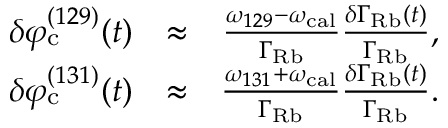<formula> <loc_0><loc_0><loc_500><loc_500>\begin{array} { r l r } { \delta \varphi _ { c } ^ { ( 1 2 9 ) } ( t ) } & { \approx } & { \frac { \omega _ { 1 2 9 } - \omega _ { c a l } } { \Gamma _ { R b } } \frac { \delta \Gamma _ { R b } ( t ) } { \Gamma _ { R b } } , } \\ { \delta \varphi _ { c } ^ { ( 1 3 1 ) } ( t ) } & { \approx } & { \frac { \omega _ { 1 3 1 } + \omega _ { c a l } } { \Gamma _ { R b } } \frac { \delta \Gamma _ { R b } ( t ) } { \Gamma _ { R b } } . } \end{array}</formula> 